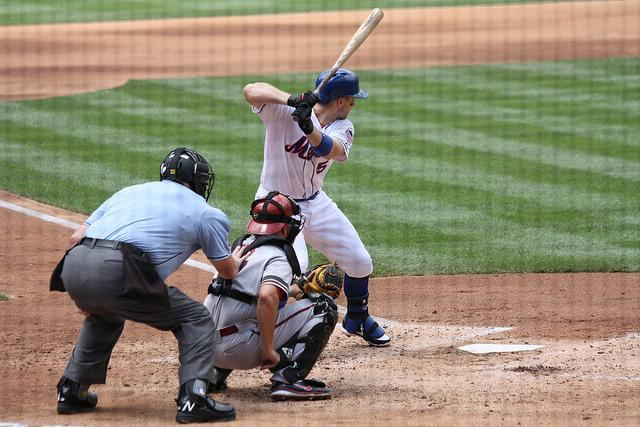What number is the batter?

Choices:
A) five
B) 42
C) 12
D) nine five 